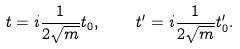Convert formula to latex. <formula><loc_0><loc_0><loc_500><loc_500>t = i \frac { 1 } { 2 \sqrt { m } } t _ { 0 } , \quad t ^ { \prime } = i \frac { 1 } { 2 \sqrt { m } } t _ { 0 } ^ { \prime } .</formula> 